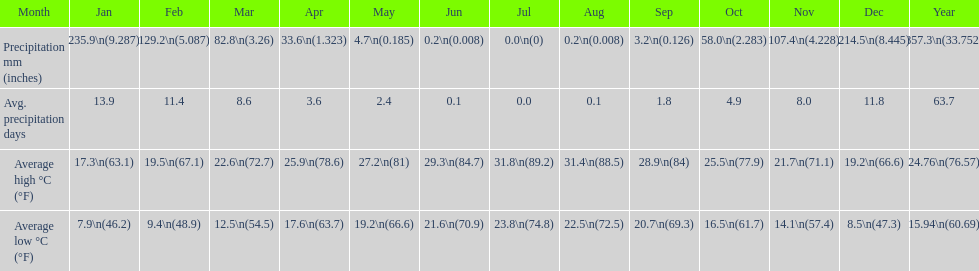Which country is haifa in? Israel. 